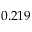<formula> <loc_0><loc_0><loc_500><loc_500>0 . 2 1 9</formula> 